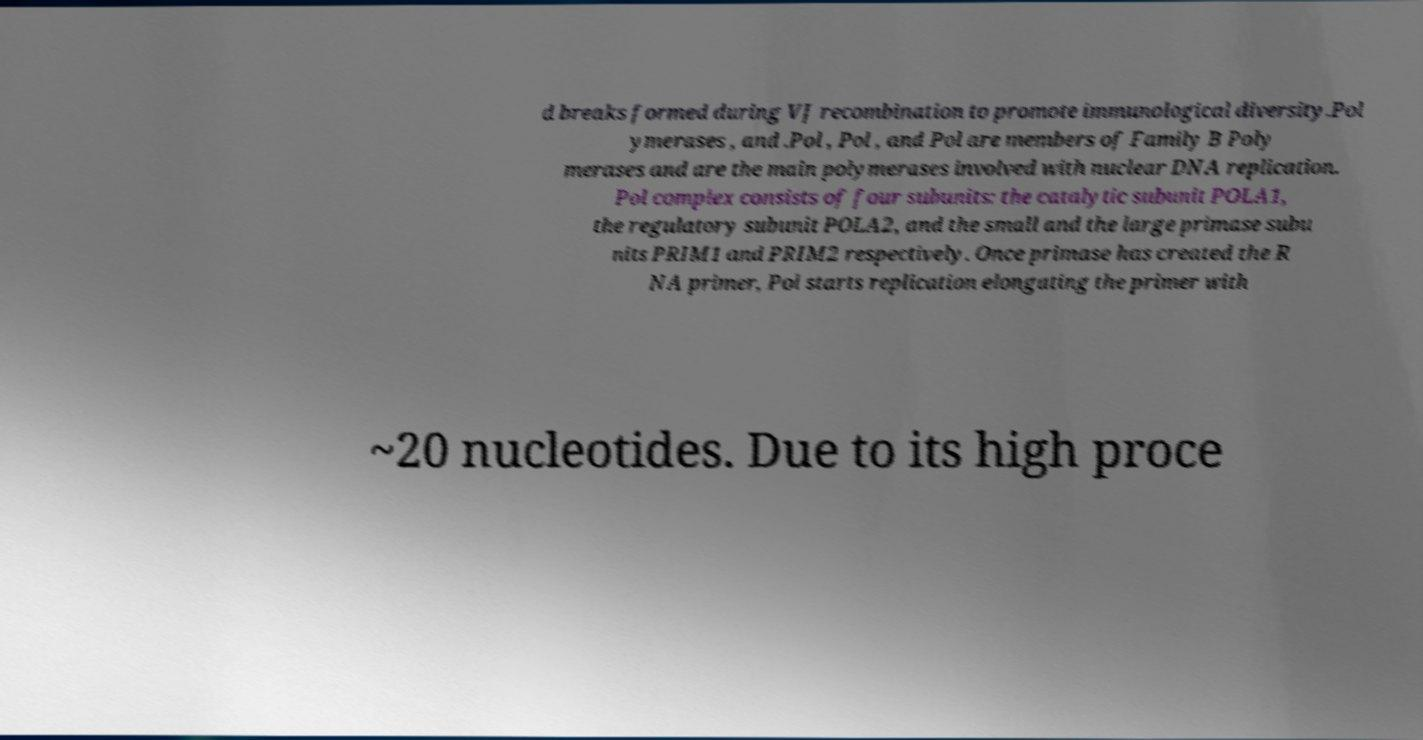Can you accurately transcribe the text from the provided image for me? d breaks formed during VJ recombination to promote immunological diversity.Pol ymerases , and .Pol , Pol , and Pol are members of Family B Poly merases and are the main polymerases involved with nuclear DNA replication. Pol complex consists of four subunits: the catalytic subunit POLA1, the regulatory subunit POLA2, and the small and the large primase subu nits PRIM1 and PRIM2 respectively. Once primase has created the R NA primer, Pol starts replication elongating the primer with ~20 nucleotides. Due to its high proce 